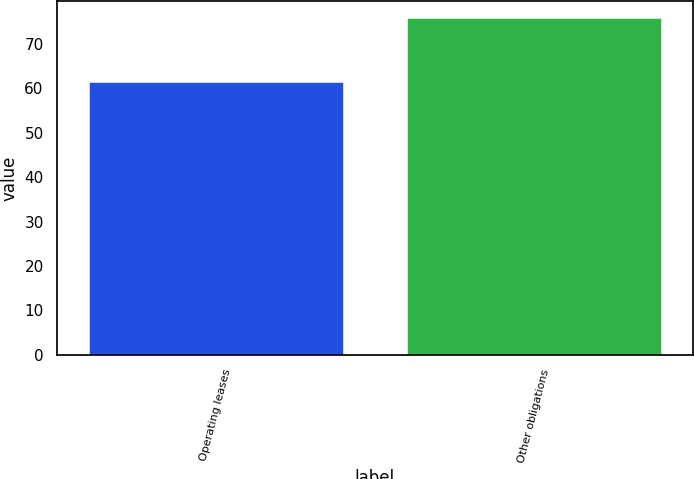Convert chart. <chart><loc_0><loc_0><loc_500><loc_500><bar_chart><fcel>Operating leases<fcel>Other obligations<nl><fcel>61.4<fcel>75.8<nl></chart> 